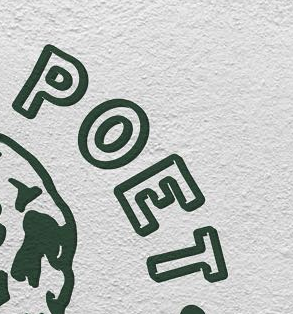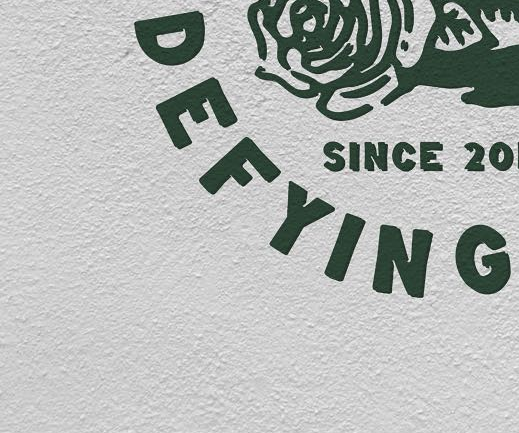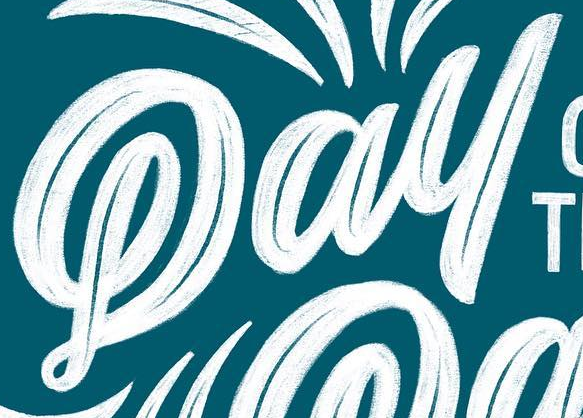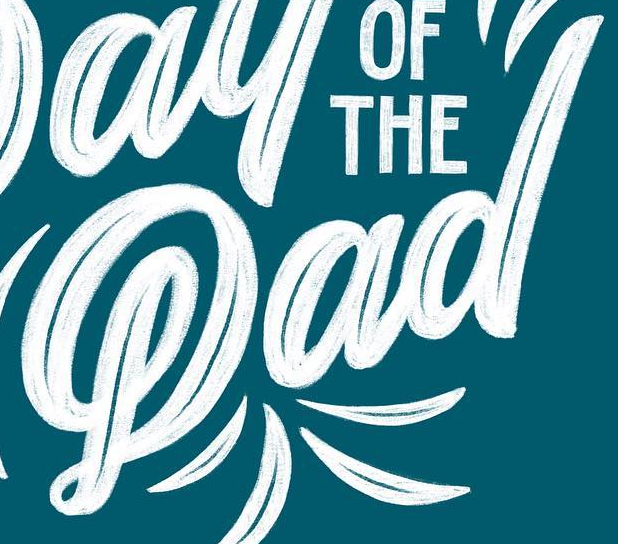What words can you see in these images in sequence, separated by a semicolon? POET; DEFYING; Pay; Pad 